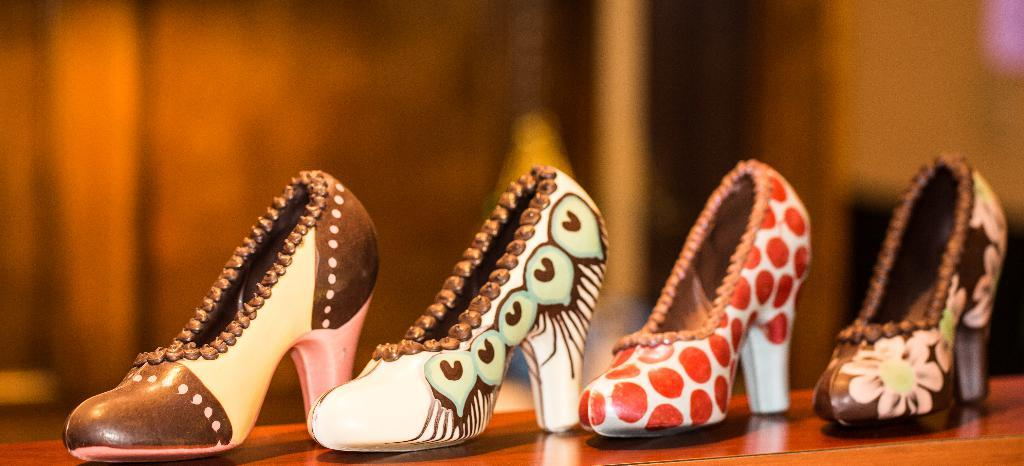What is located in the foreground of the image? There is footwear in the foreground of the image. Can you describe the background of the image? The background of the image is blurry. What type of bait is being used to catch fish in the image? There is no indication of fishing or bait in the image; it only features footwear in the foreground and a blurry background. 